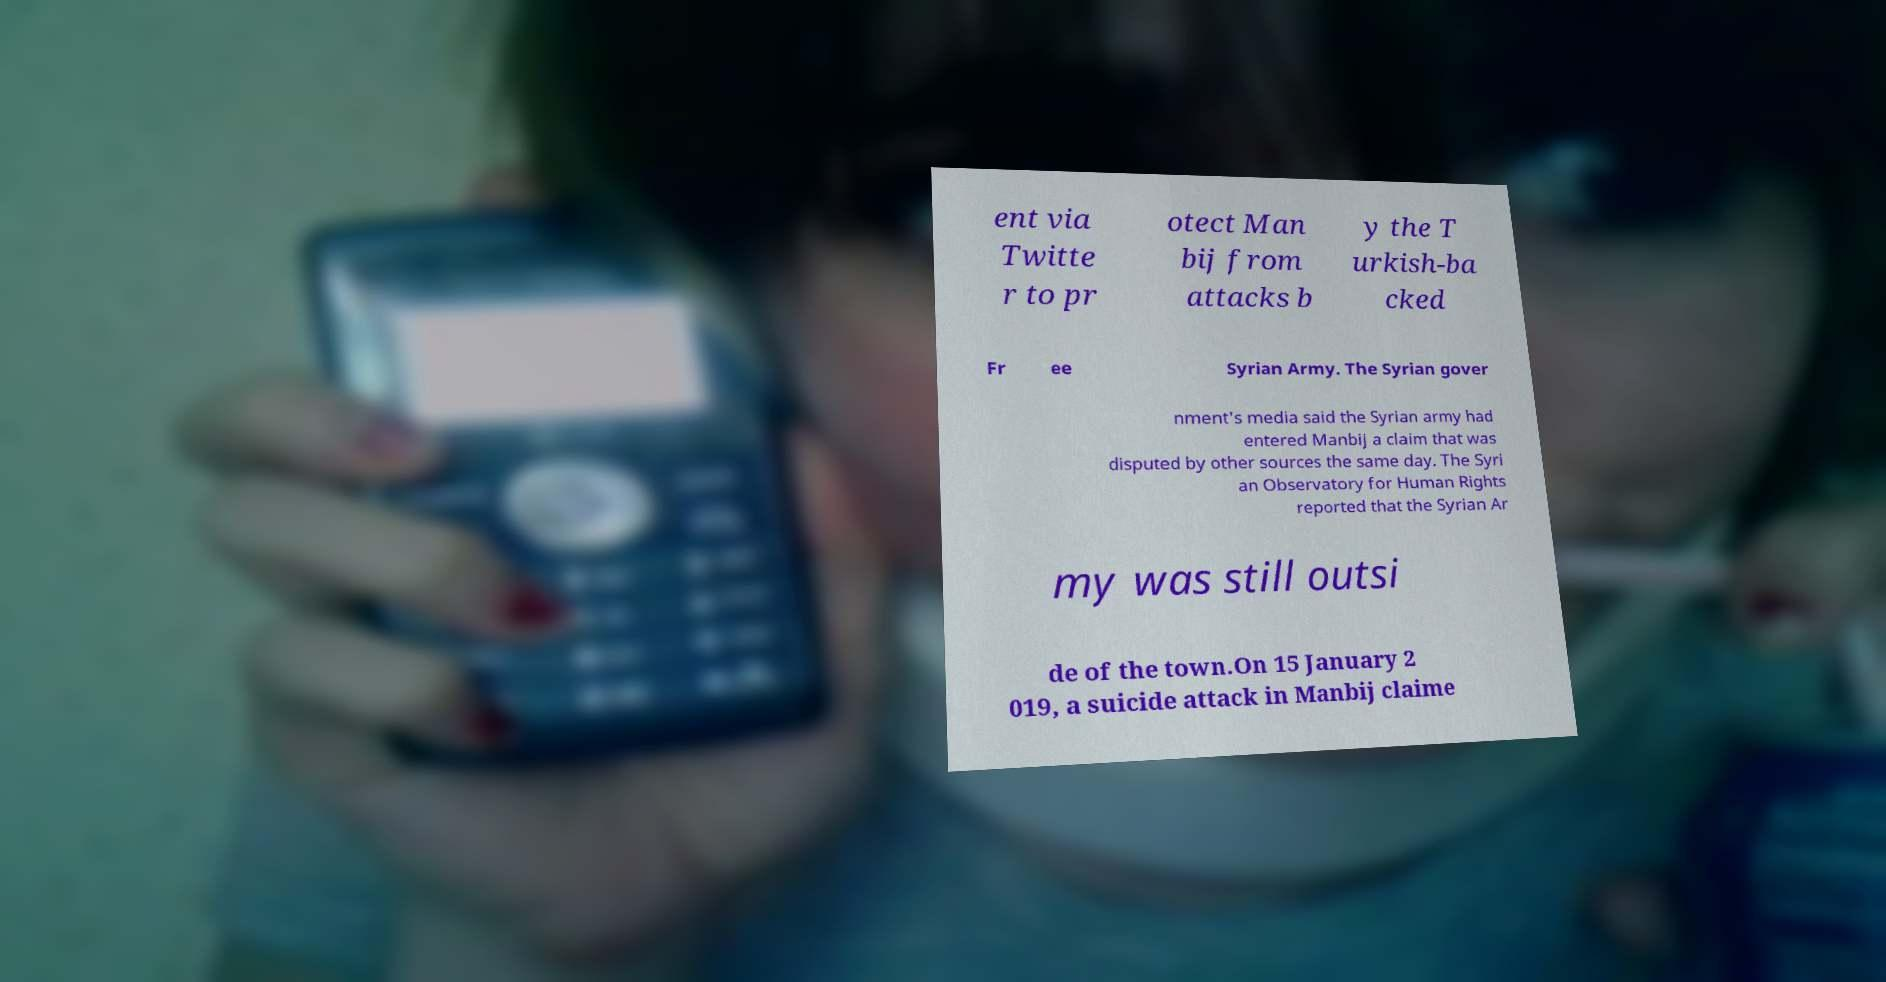Can you read and provide the text displayed in the image?This photo seems to have some interesting text. Can you extract and type it out for me? ent via Twitte r to pr otect Man bij from attacks b y the T urkish-ba cked Fr ee Syrian Army. The Syrian gover nment's media said the Syrian army had entered Manbij a claim that was disputed by other sources the same day. The Syri an Observatory for Human Rights reported that the Syrian Ar my was still outsi de of the town.On 15 January 2 019, a suicide attack in Manbij claime 